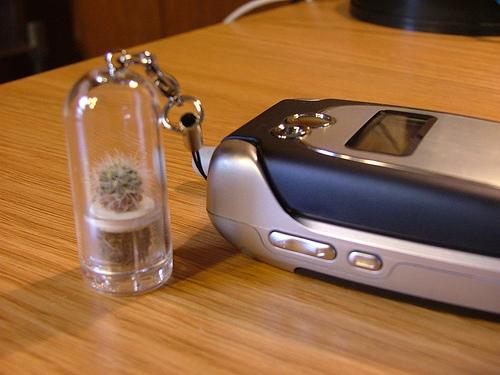Is the table wood?
Write a very short answer. Yes. What is on the desk?
Short answer required. Cell phone. What color is the cell phone?
Give a very brief answer. Blue and silver. 